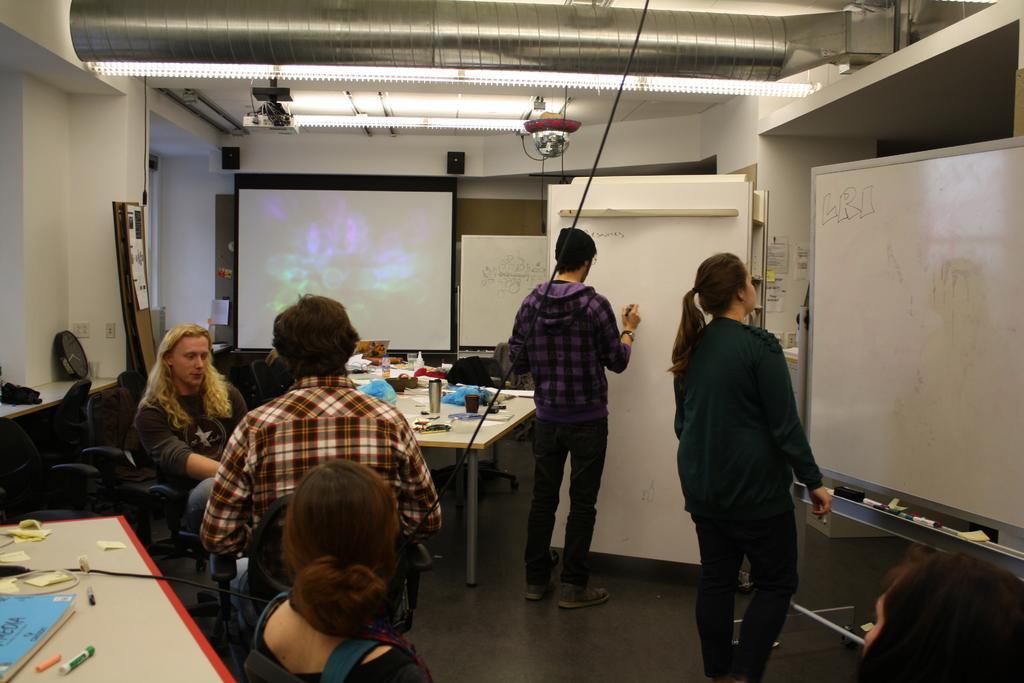Can you describe this image briefly? In this picture we can see some persons sitting on the chairs. This is table. On the table there is a book, marker, and papers. Here we can see two persons standing on the floor. These are the boards. Here we can see a screen and these are the lights. 